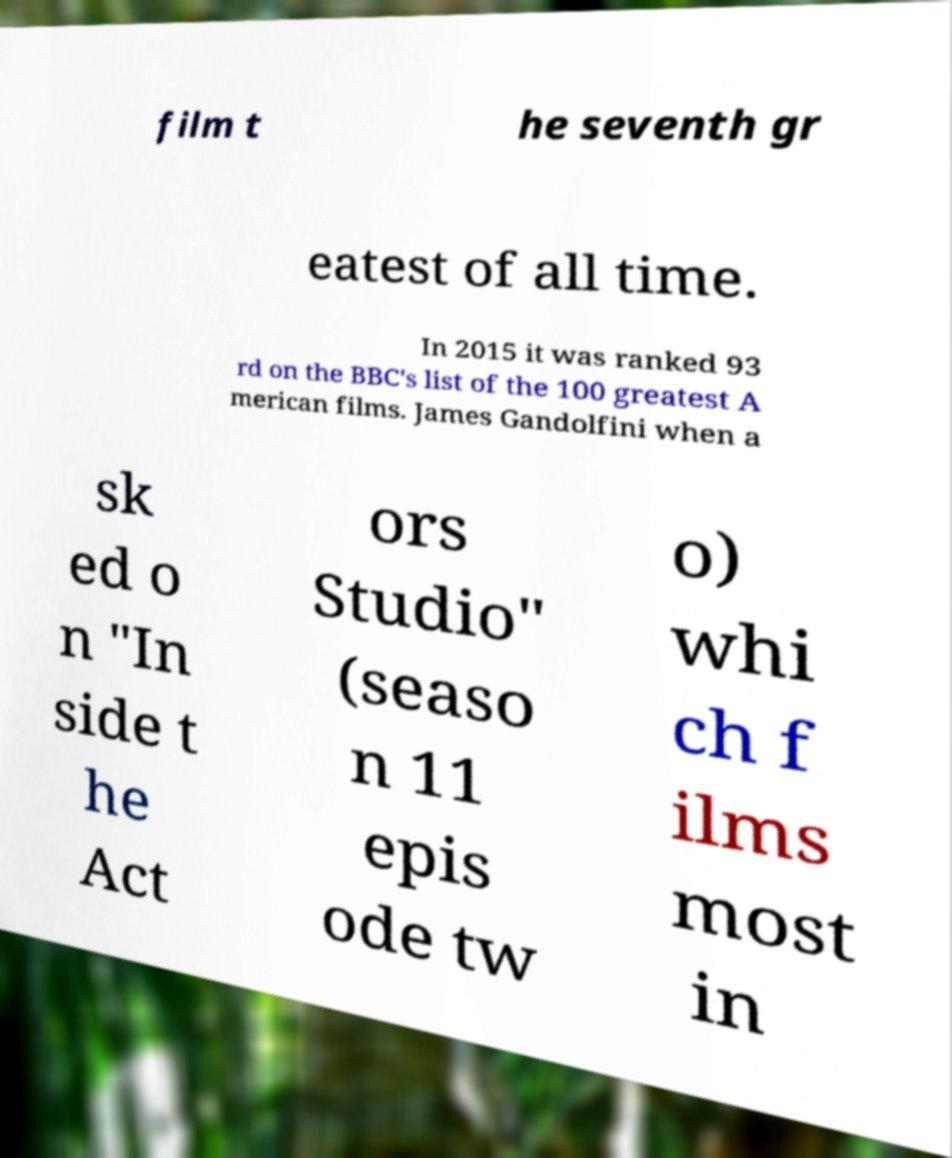Can you accurately transcribe the text from the provided image for me? film t he seventh gr eatest of all time. In 2015 it was ranked 93 rd on the BBC's list of the 100 greatest A merican films. James Gandolfini when a sk ed o n "In side t he Act ors Studio" (seaso n 11 epis ode tw o) whi ch f ilms most in 